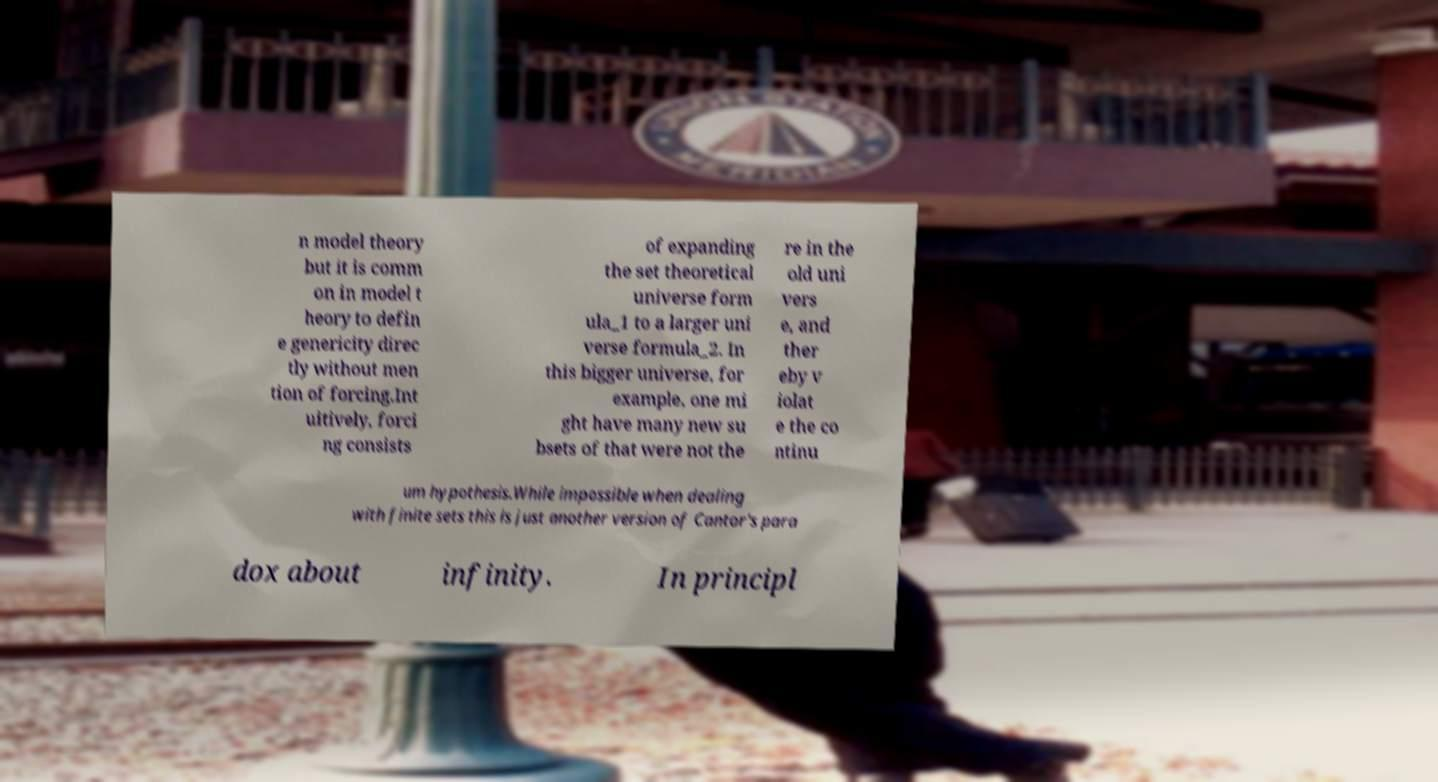I need the written content from this picture converted into text. Can you do that? n model theory but it is comm on in model t heory to defin e genericity direc tly without men tion of forcing.Int uitively, forci ng consists of expanding the set theoretical universe form ula_1 to a larger uni verse formula_2. In this bigger universe, for example, one mi ght have many new su bsets of that were not the re in the old uni vers e, and ther eby v iolat e the co ntinu um hypothesis.While impossible when dealing with finite sets this is just another version of Cantor's para dox about infinity. In principl 